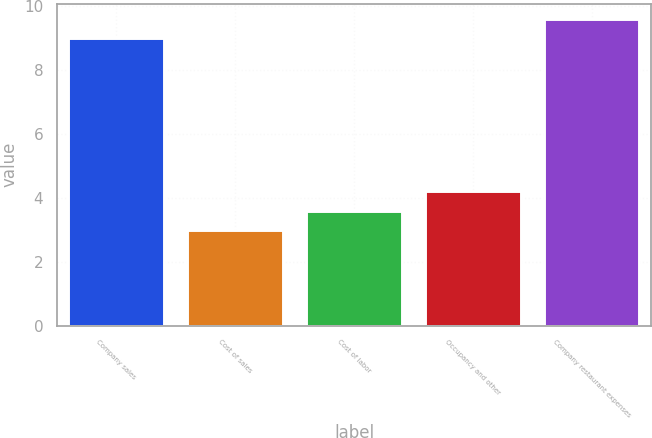<chart> <loc_0><loc_0><loc_500><loc_500><bar_chart><fcel>Company sales<fcel>Cost of sales<fcel>Cost of labor<fcel>Occupancy and other<fcel>Company restaurant expenses<nl><fcel>9<fcel>3<fcel>3.6<fcel>4.2<fcel>9.6<nl></chart> 